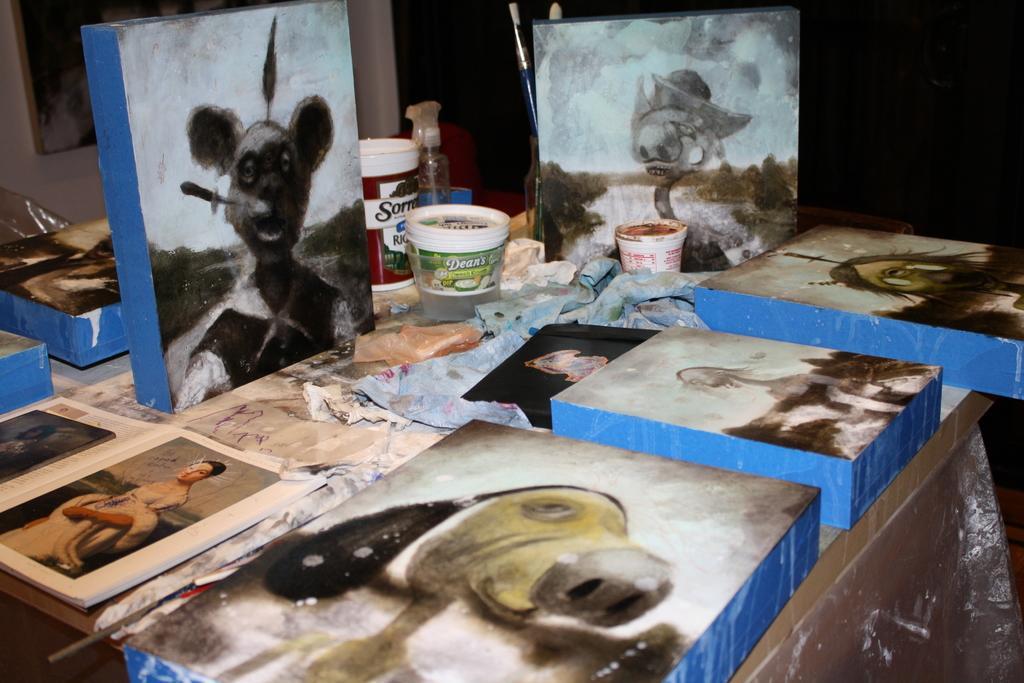Could you give a brief overview of what you see in this image? In the center of the image we can see books, objects, containers placed on the table. In the background we can see photo frame and wall. 